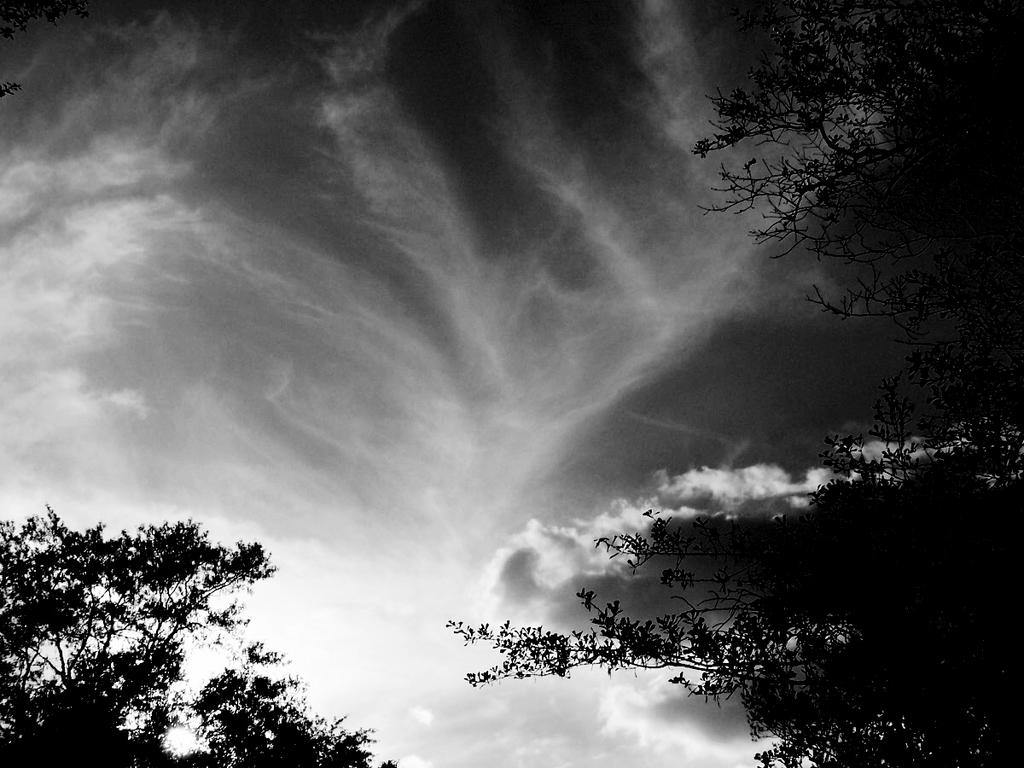What is the color scheme of the image? The image is black and white. Where was the image taken? The image was taken outdoors. What can be seen in the background of the image? There is a sky with clouds in the background. How many trees are on the left side of the image? There are two trees on the left side of the image. How many trees are on the right side of the image? There are two trees on the right side of the image. Can you see any icicles hanging from the trees in the image? There are no icicles present in the image, as it is taken outdoors and the trees are not covered in ice. Is there a baseball game taking place in the image? There is no baseball game present in the image; it features trees and a sky with clouds. 